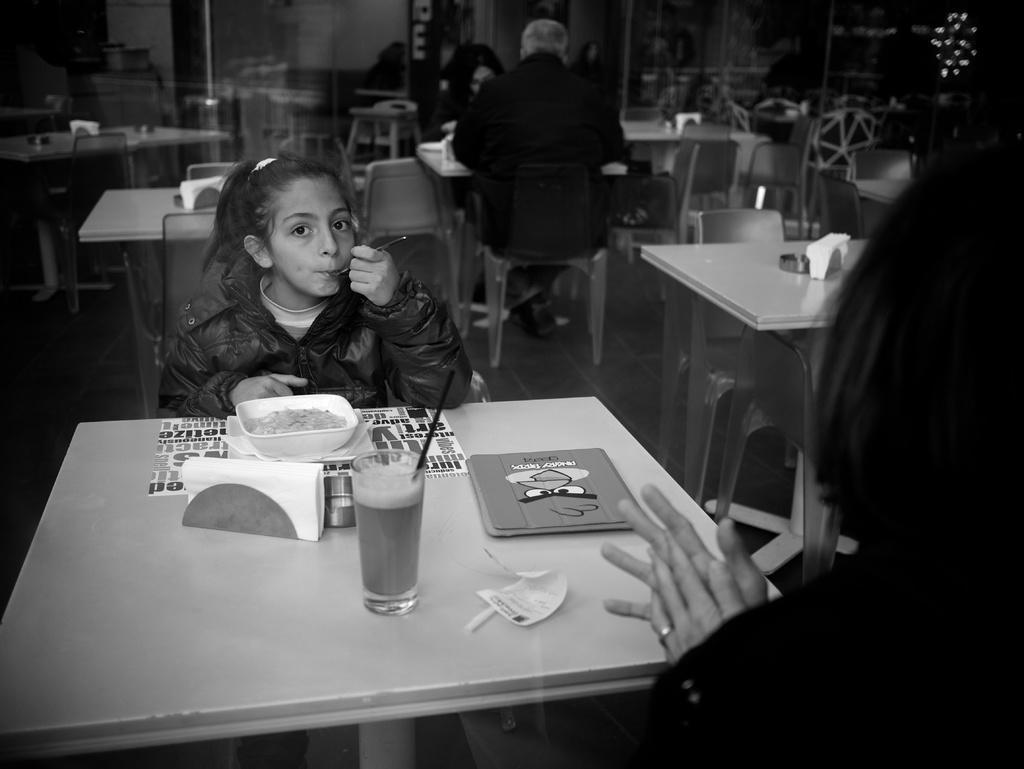In one or two sentences, can you explain what this image depicts? In this image I can see few people are sitting on chairs. I can also see number of chairs and tables. here on this table I can see a glass, food in plate and few napkins. 